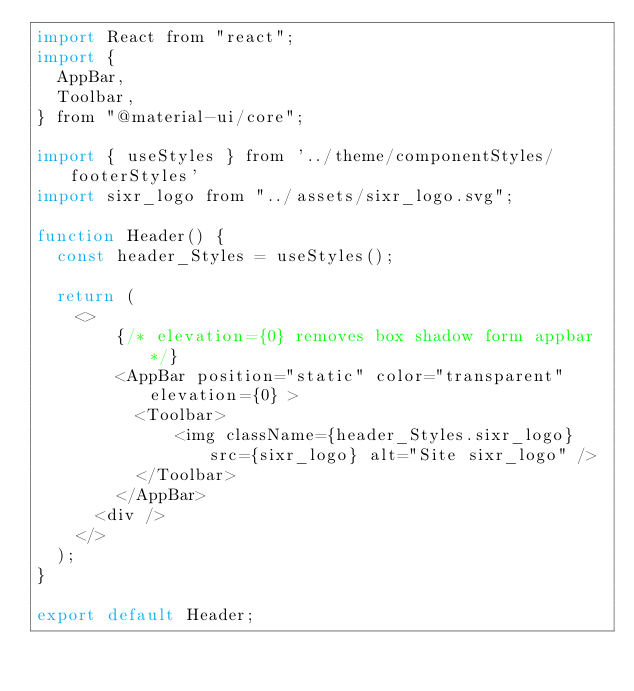Convert code to text. <code><loc_0><loc_0><loc_500><loc_500><_JavaScript_>import React from "react";
import {
  AppBar,
  Toolbar,
} from "@material-ui/core";

import { useStyles } from '../theme/componentStyles/footerStyles'
import sixr_logo from "../assets/sixr_logo.svg";

function Header() {
  const header_Styles = useStyles();

  return (
    <>
        {/* elevation={0} removes box shadow form appbar */}
        <AppBar position="static" color="transparent" elevation={0} >
          <Toolbar>
              <img className={header_Styles.sixr_logo} src={sixr_logo} alt="Site sixr_logo" />
          </Toolbar>
        </AppBar>
      <div />
    </>
  );
}

export default Header;
</code> 